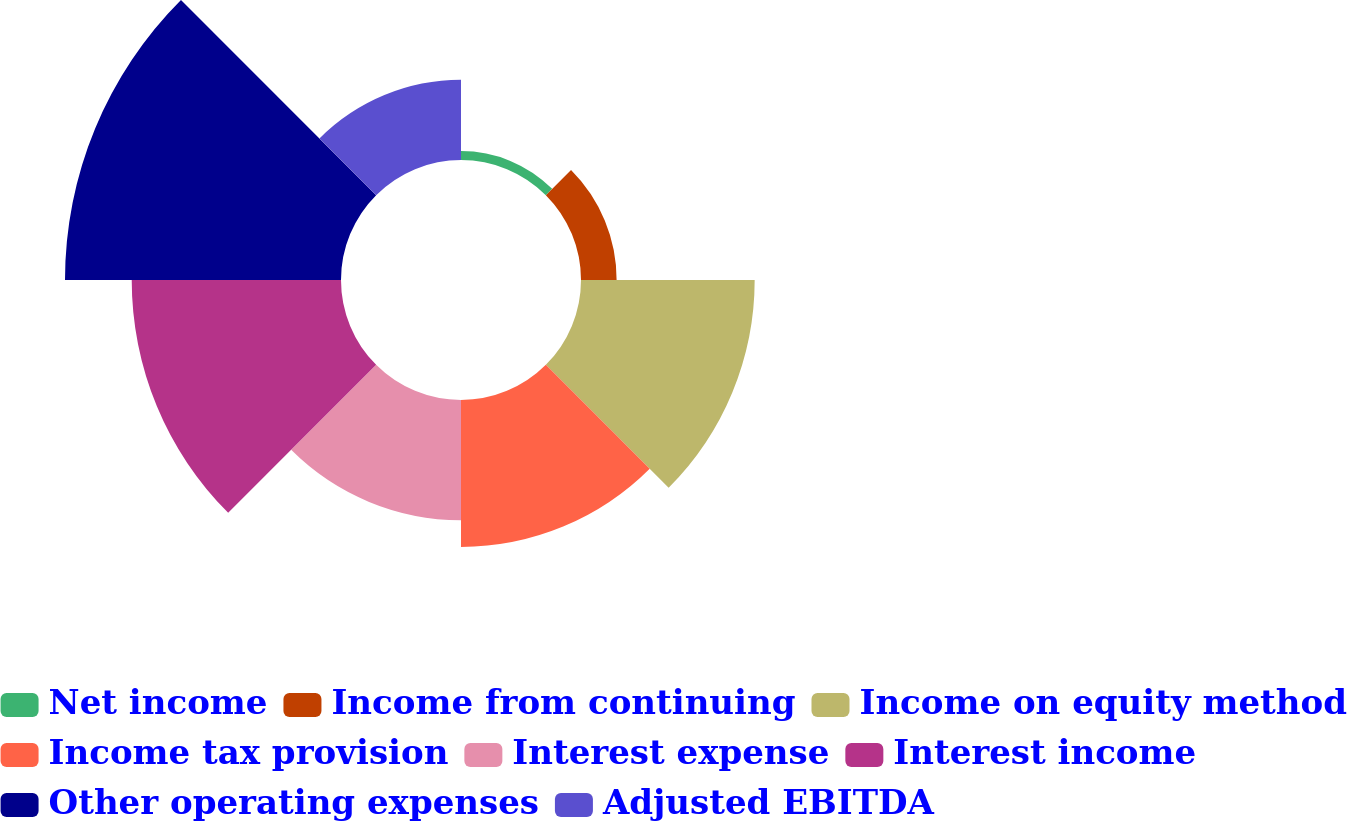Convert chart. <chart><loc_0><loc_0><loc_500><loc_500><pie_chart><fcel>Net income<fcel>Income from continuing<fcel>Income on equity method<fcel>Income tax provision<fcel>Interest expense<fcel>Interest income<fcel>Other operating expenses<fcel>Adjusted EBITDA<nl><fcel>0.85%<fcel>3.39%<fcel>16.53%<fcel>13.98%<fcel>11.44%<fcel>19.92%<fcel>26.27%<fcel>7.63%<nl></chart> 